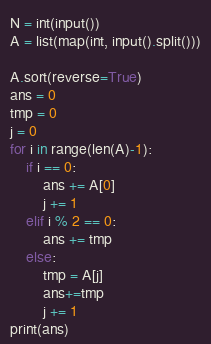Convert code to text. <code><loc_0><loc_0><loc_500><loc_500><_Python_>N = int(input())
A = list(map(int, input().split()))

A.sort(reverse=True)
ans = 0
tmp = 0
j = 0
for i in range(len(A)-1):
    if i == 0:
        ans += A[0]
        j += 1
    elif i % 2 == 0:
        ans += tmp
    else:
        tmp = A[j]
        ans+=tmp
        j += 1
print(ans)</code> 